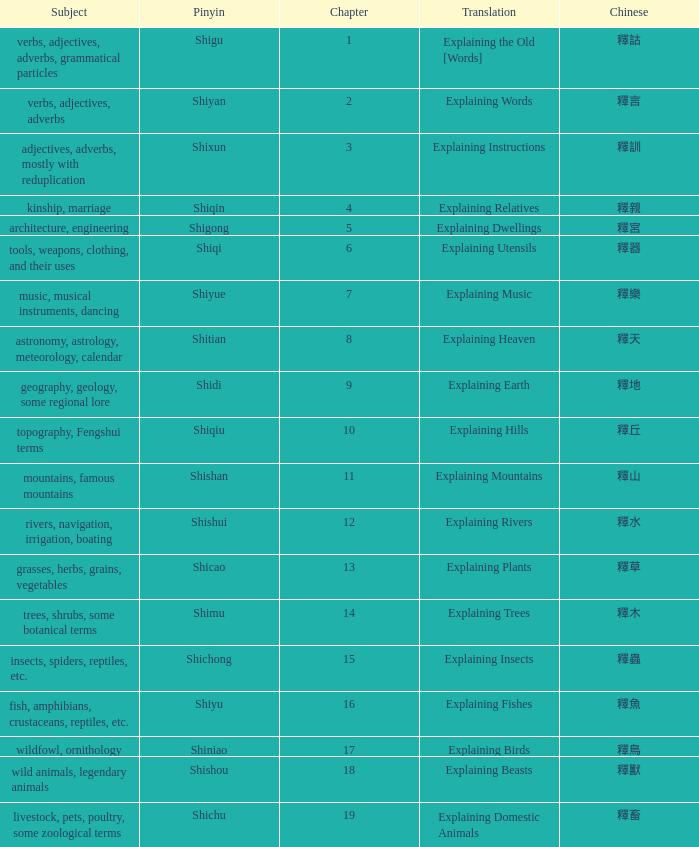Name the highest chapter with chinese of 釋言 2.0. 